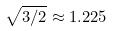Convert formula to latex. <formula><loc_0><loc_0><loc_500><loc_500>\sqrt { 3 / 2 } \approx 1 . 2 2 5</formula> 